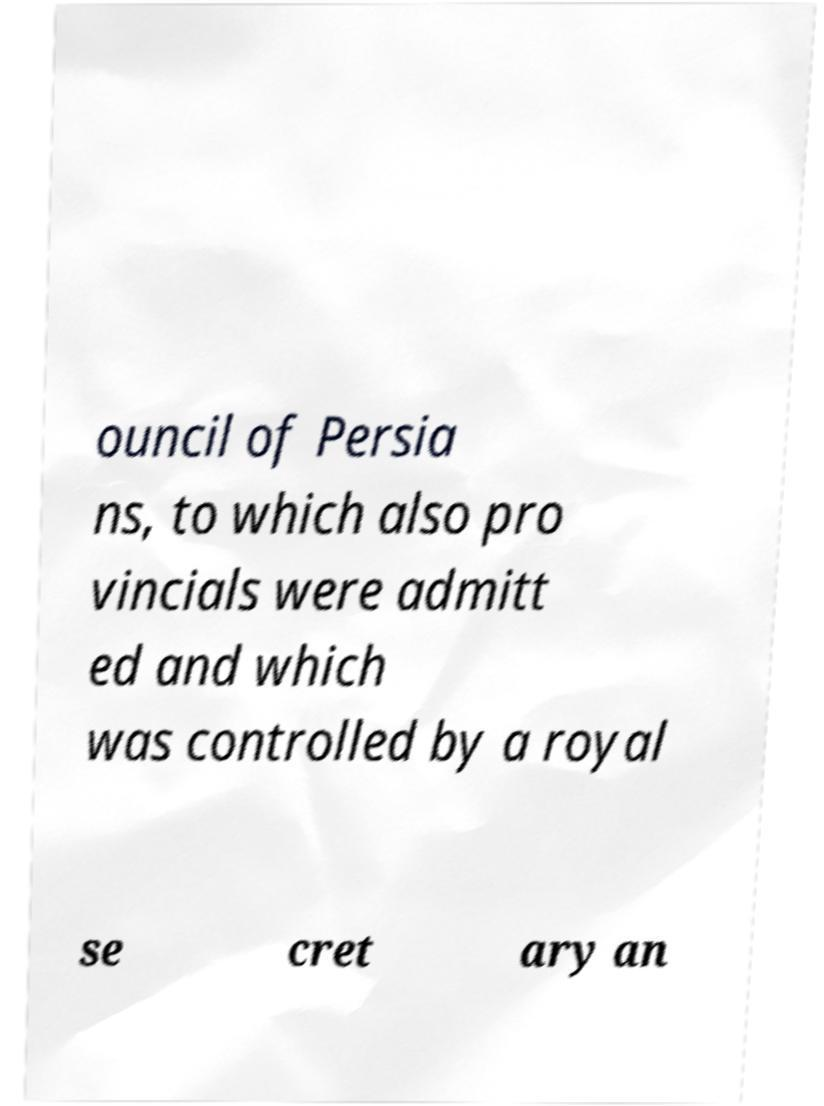Can you accurately transcribe the text from the provided image for me? ouncil of Persia ns, to which also pro vincials were admitt ed and which was controlled by a royal se cret ary an 